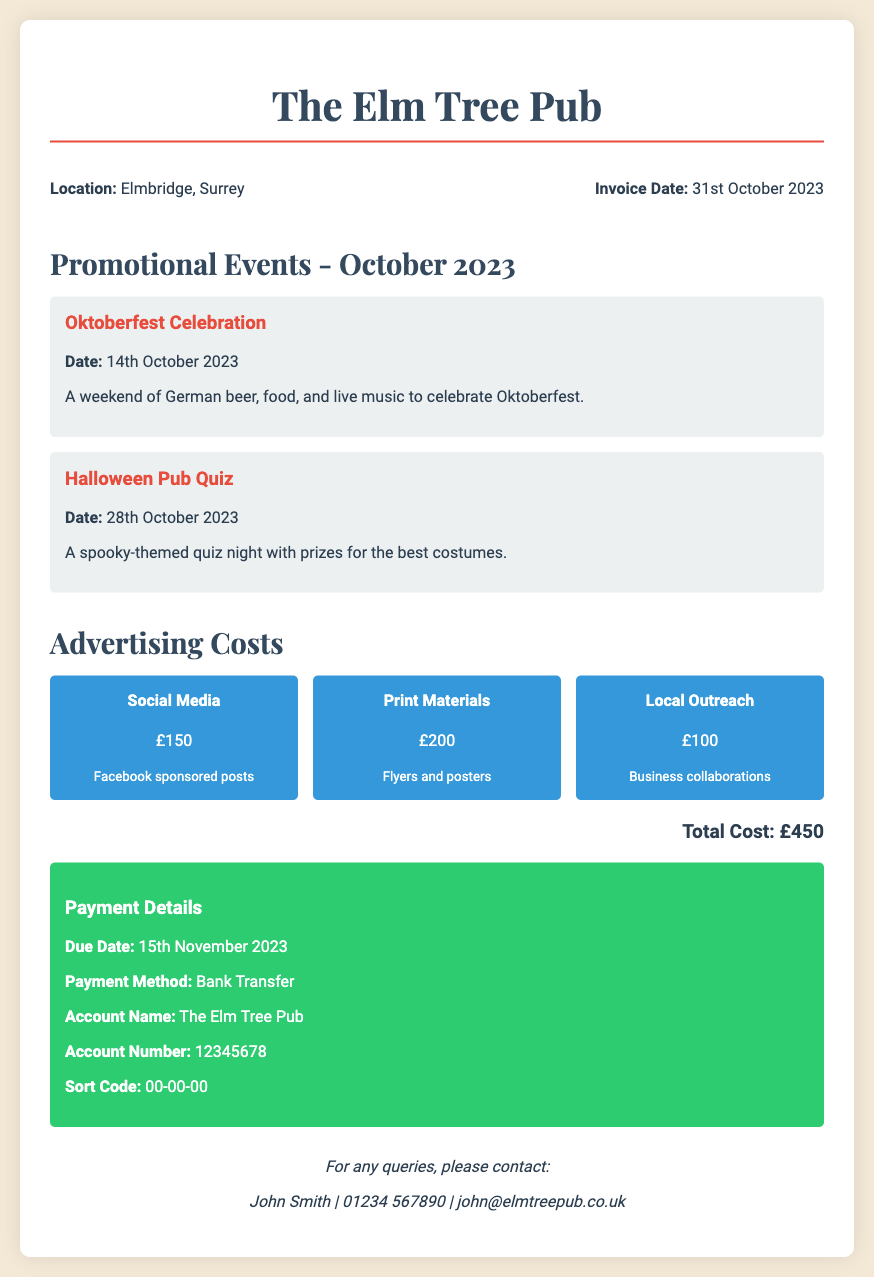What is the invoice date? The invoice date is specified in the document, indicating when the invoice was created.
Answer: 31st October 2023 What is the total advertising cost? The total advertising cost is calculated from the sum of individual advertising expenses listed in the document.
Answer: £450 What types of events were held at the pub in October 2023? The document lists two events, providing details about each.
Answer: Oktoberfest Celebration, Halloween Pub Quiz What is the cost for Social Media advertising? The cost for Social Media advertising is indicated directly as part of the advertising costs.
Answer: £150 What is the due date for payment? The due date for payment is stated clearly in the payment section of the document.
Answer: 15th November 2023 What payment method is accepted? The document specifies how payments should be made.
Answer: Bank Transfer How much did the Print Materials cost? The cost for Print Materials is provided in the document under advertising costs.
Answer: £200 Who should be contacted for queries? The document provides a contact person for any questions regarding the invoice.
Answer: John Smith What is the location of The Elm Tree Pub? The location is specified in the pub information section of the document.
Answer: Elmbridge, Surrey 